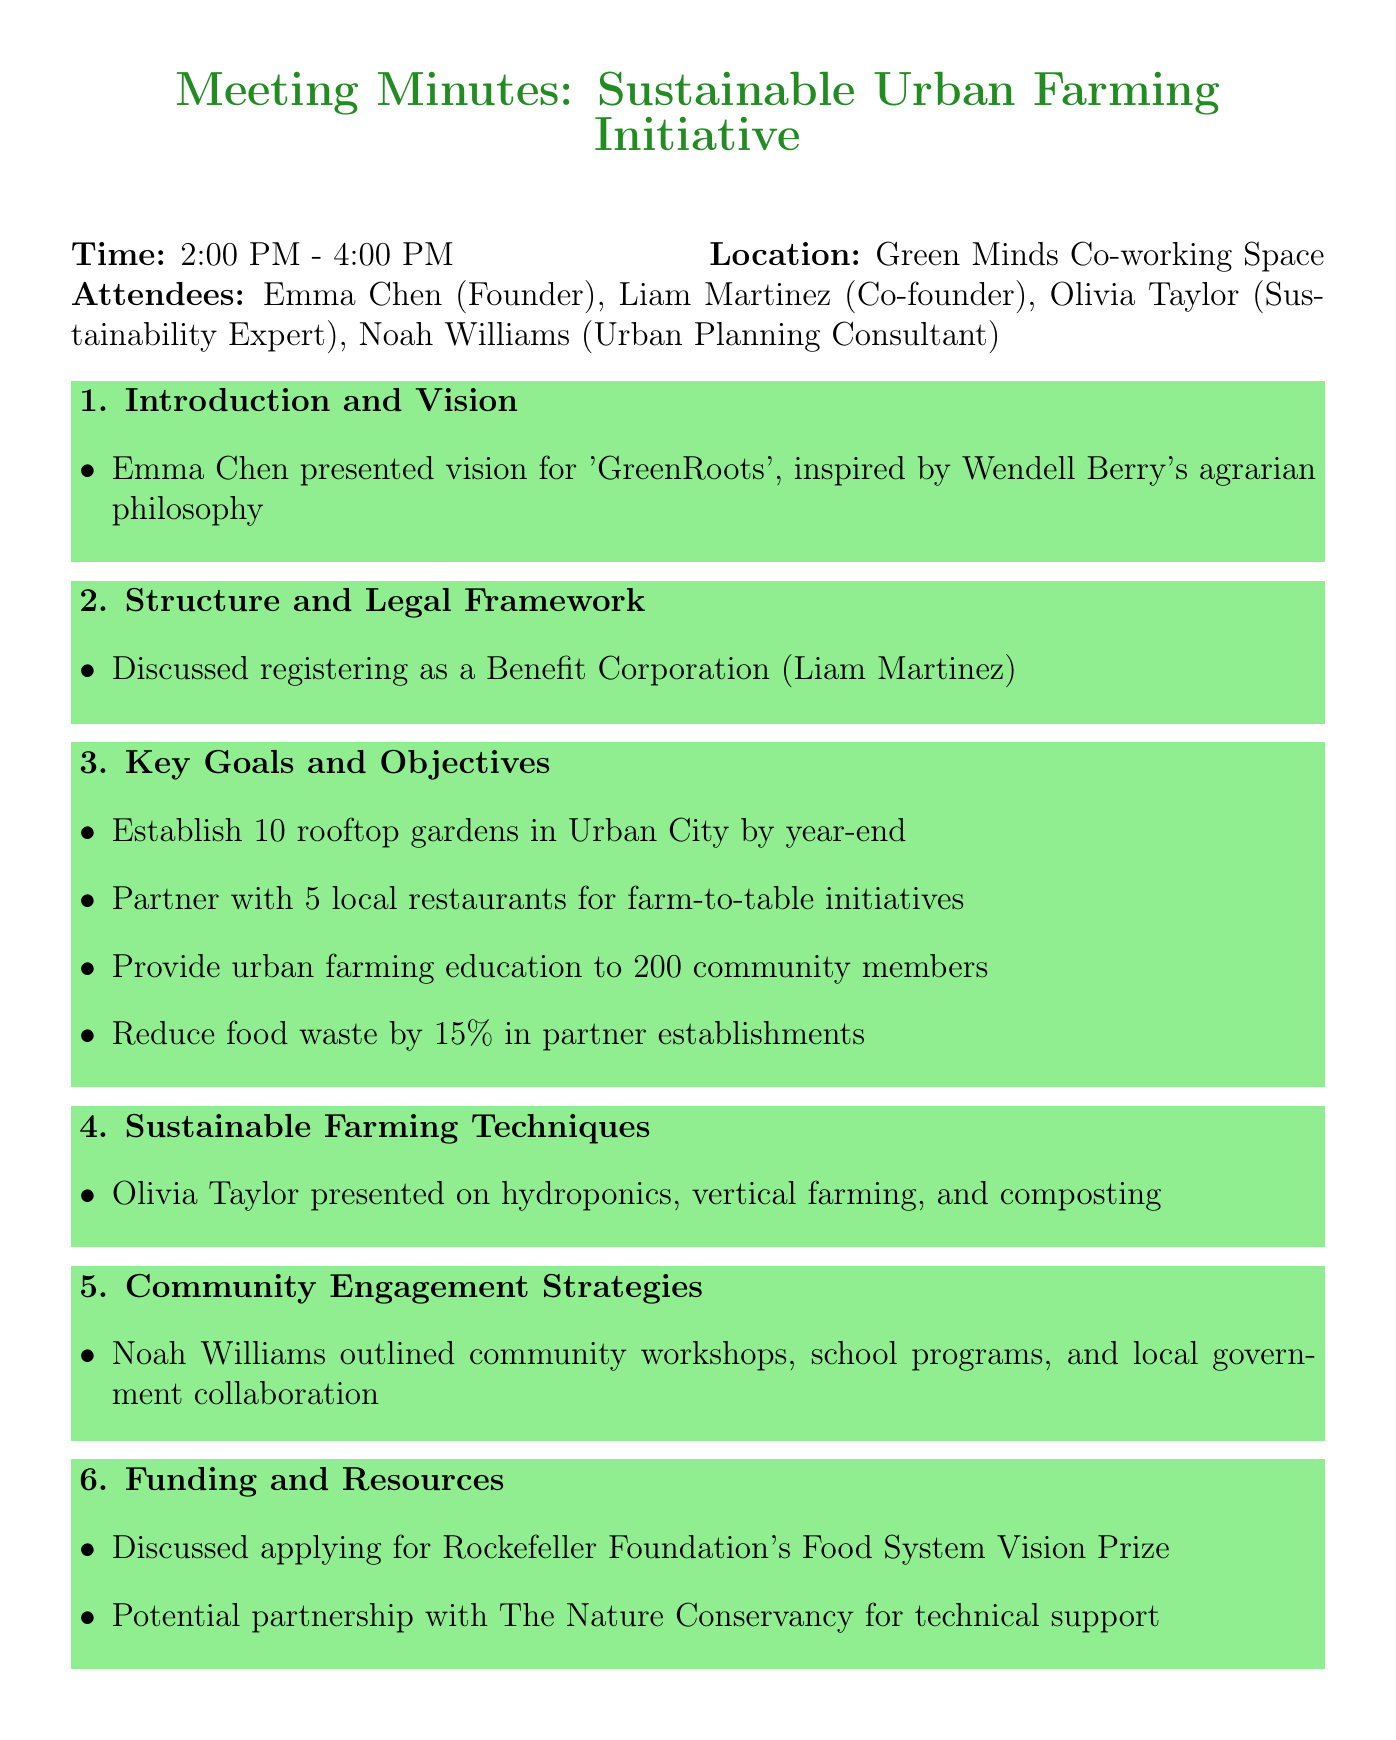What is the name of the social enterprise discussed? The document states that the name of the social enterprise is 'GreenRoots'.
Answer: GreenRoots Who led the discussion on registering as a Benefit Corporation? Liam Martinez is mentioned as the one who led the discussion on the legal framework.
Answer: Liam Martinez When is Emma expected to finalize the business plan? Emma's deadline for finalizing the business plan is specified in the next steps section.
Answer: May 30 How many rooftop gardens are planned to be established? The key goals detail indicates the target for rooftop gardens in Urban City.
Answer: 10 What percentage reduction in food waste is targeted? The document specifies a goal to reduce food waste by a certain percentage in partner establishments.
Answer: 15% Which techniques were presented by Olivia Taylor? The document details sustainable farming techniques presented by Olivia Taylor.
Answer: hydroponics, vertical farming, and composting What is one of the partnership goals listed in the key objectives? The objectives include partnering with local restaurants for a specific initiative.
Answer: farm-to-table initiatives What strategy outlines community engagement? Noah Williams outlined strategies related to community involvement in the document.
Answer: community workshops, school programs, and local government collaboration 